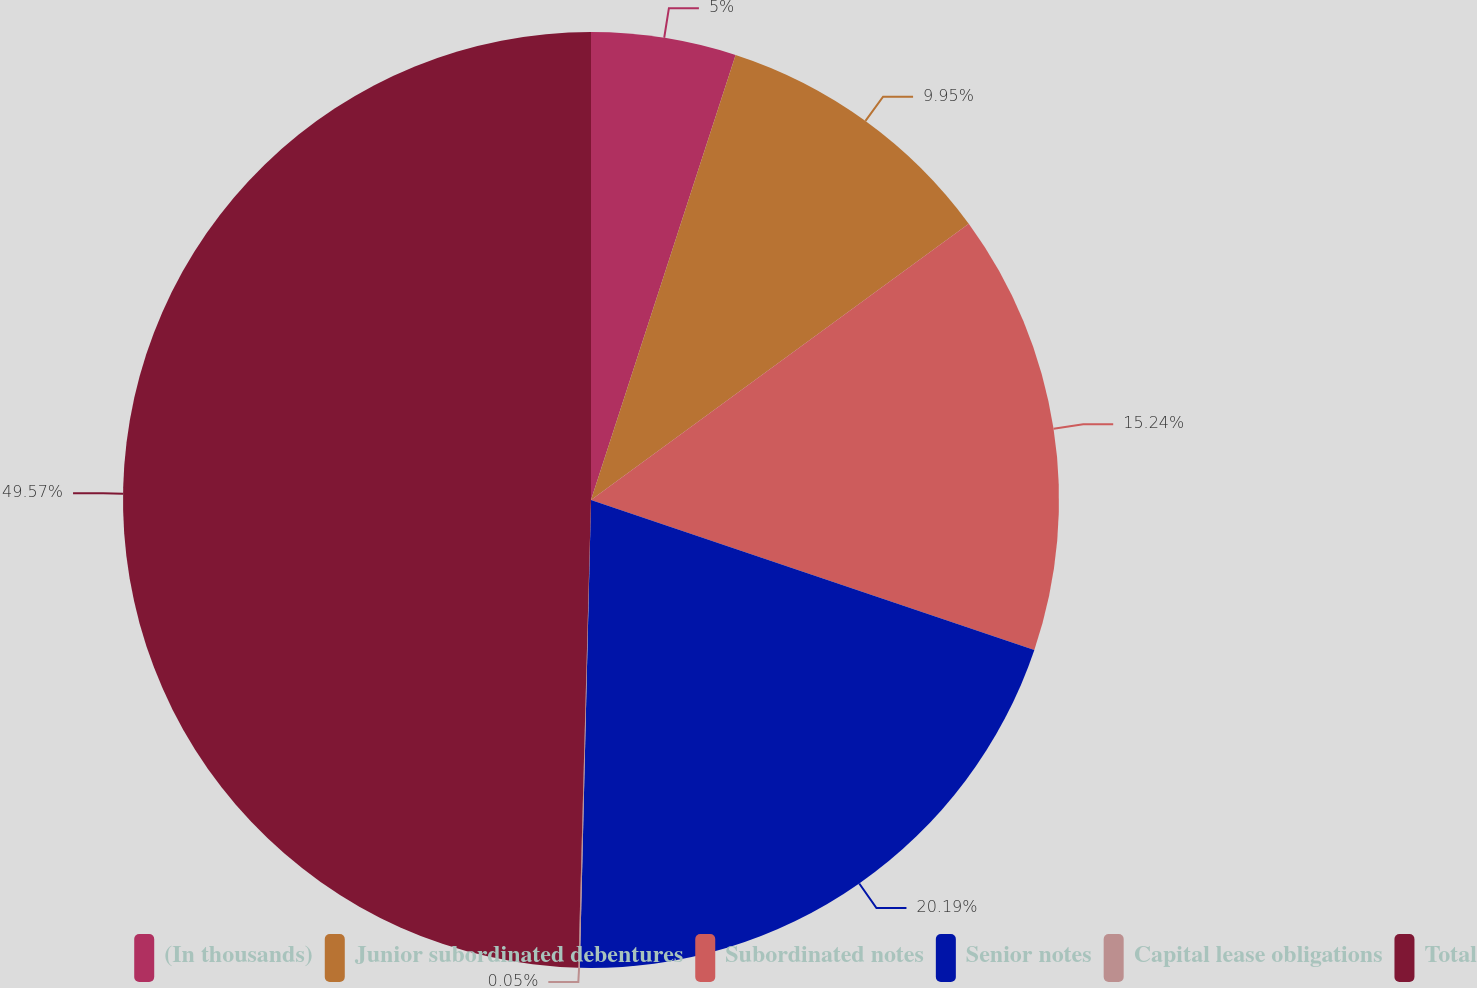Convert chart to OTSL. <chart><loc_0><loc_0><loc_500><loc_500><pie_chart><fcel>(In thousands)<fcel>Junior subordinated debentures<fcel>Subordinated notes<fcel>Senior notes<fcel>Capital lease obligations<fcel>Total<nl><fcel>5.0%<fcel>9.95%<fcel>15.24%<fcel>20.19%<fcel>0.05%<fcel>49.57%<nl></chart> 